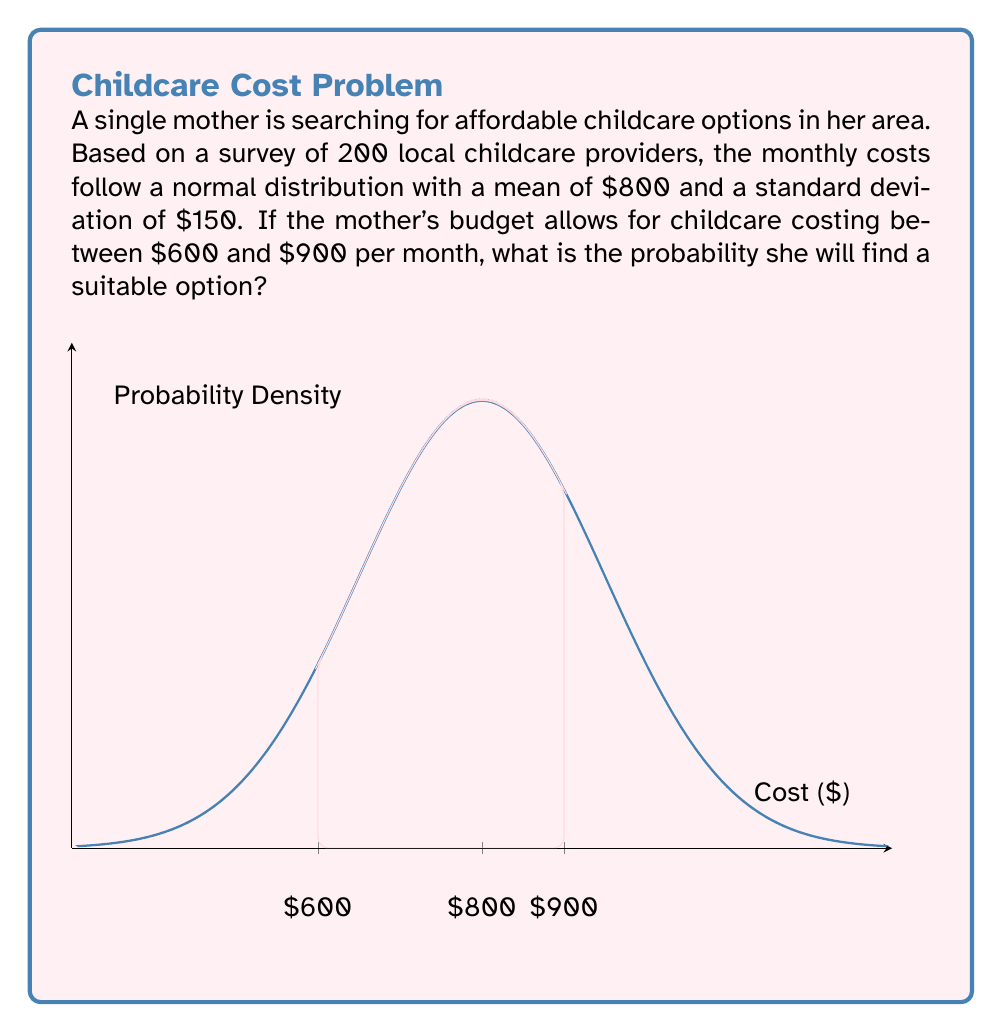Can you answer this question? To solve this problem, we need to use the properties of the normal distribution and calculate the area under the curve between $600 and $900.

Step 1: Standardize the z-scores for the lower and upper bounds.
For $600: $z_1 = \frac{600 - 800}{150} = -1.33$
For $900: $z_2 = \frac{900 - 800}{150} = 0.67$

Step 2: Use the standard normal distribution table or a calculator to find the area under the curve for these z-scores.
$P(Z \leq -1.33) \approx 0.0918$
$P(Z \leq 0.67) \approx 0.7486$

Step 3: Calculate the difference between these probabilities to find the area between $600 and $900.
$P(600 \leq X \leq 900) = P(Z \leq 0.67) - P(Z \leq -1.33)$
$= 0.7486 - 0.0918 = 0.6568$

Therefore, the probability of finding a suitable childcare option within the mother's budget is approximately 0.6568 or 65.68%.
Answer: $0.6568$ or $65.68\%$ 